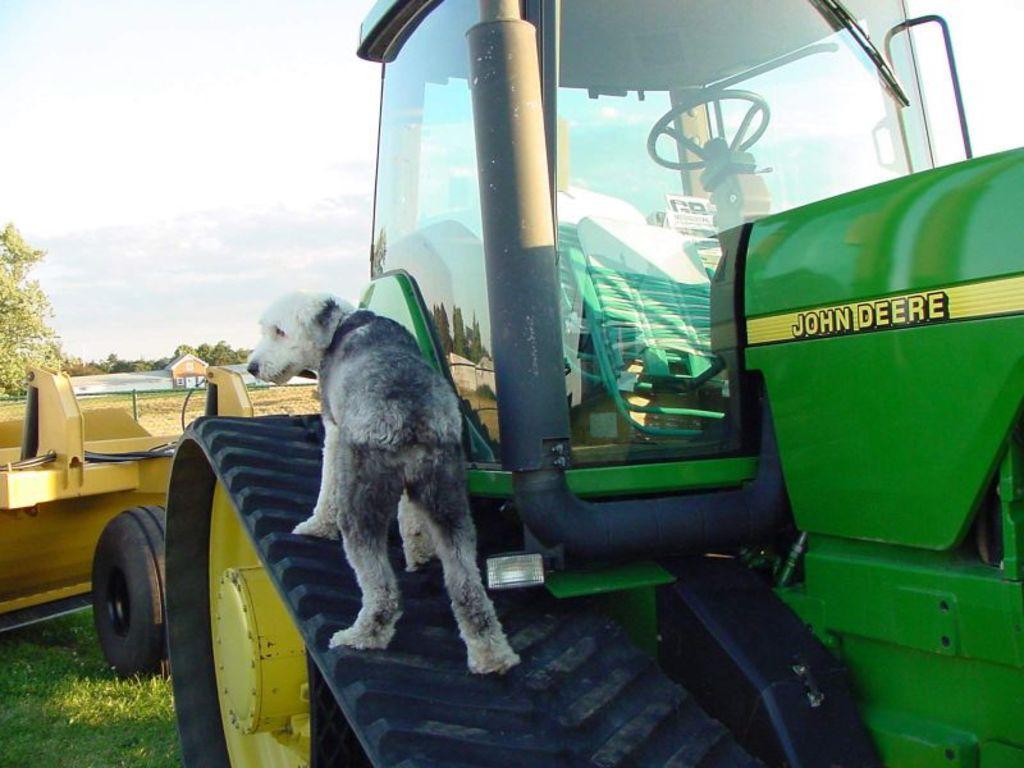Describe this image in one or two sentences. In the image there is a vehicle in the foreground and there is a dog standing on the wheel of the vehicle, in the background there is a house, an open land and trees. 